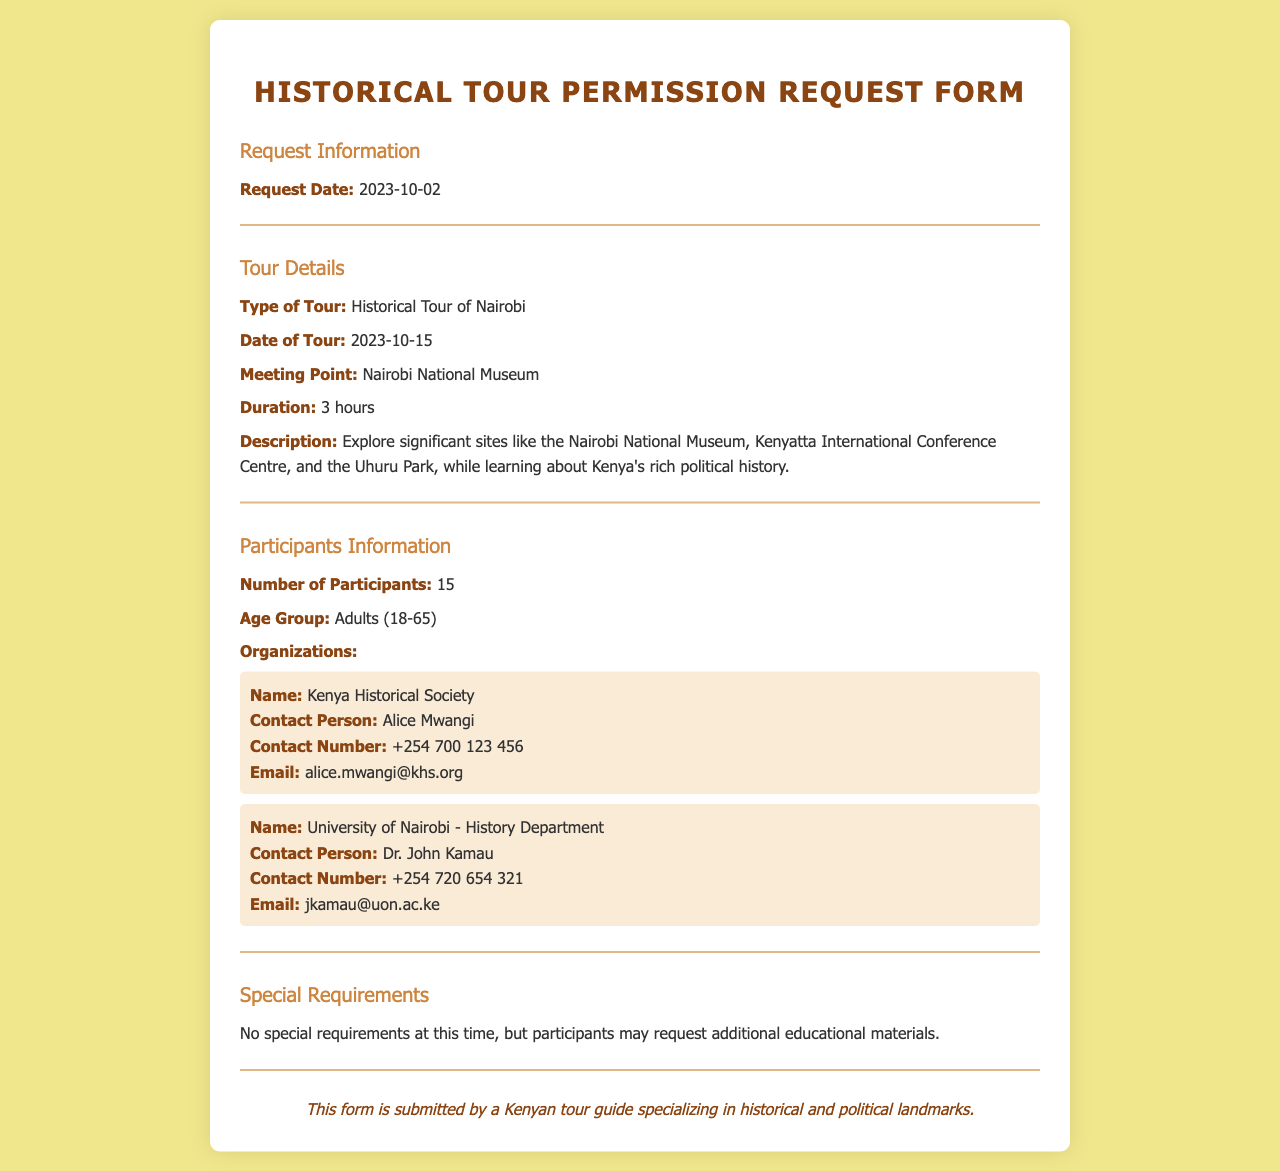What is the request date? The request date is specified in the document under the Request Information section.
Answer: 2023-10-02 What type of tour is being requested? The type of tour is detailed in the Tour Details section of the document.
Answer: Historical Tour of Nairobi What is the date of the tour? The date of the tour is mentioned alongside the type of tour in the Tour Details section.
Answer: 2023-10-15 How many participants are there? The number of participants is indicated in the Participants Information section.
Answer: 15 Who is the contact person for the Kenya Historical Society? The contact person is specified within the organization information provided in the Participants Information section.
Answer: Alice Mwangi What is the meeting point for the tour? The meeting point is listed in the Tour Details section under Meeting Point.
Answer: Nairobi National Museum What age group are the participants? The age group is found in the Participants Information section.
Answer: Adults (18-65) What is the duration of the tour? The duration is mentioned in the Tour Details section related to the tour.
Answer: 3 hours What special requirements are noted for the tour? This information can be found in the Special Requirements section of the document.
Answer: No special requirements at this time 